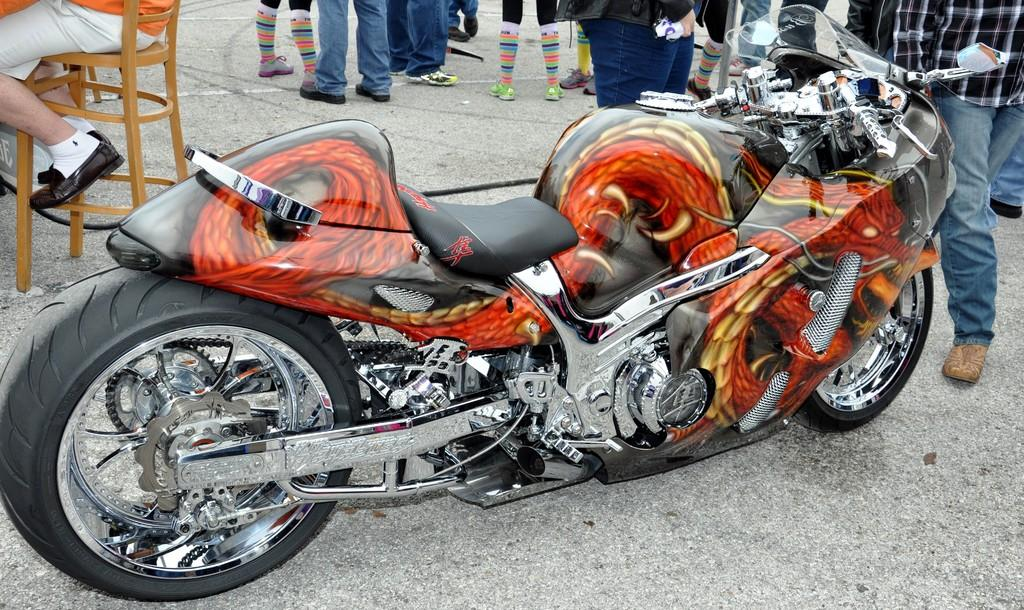What is on the road in the image? There is a bike on the road in the image. Where is the bike located? The bike is on the road. What can be seen in the background of the image? There is a person sitting on a chair and people standing on the road in the background. What grade is the bike in the image? The bike is not in a grade, as it is an object and not a student. 